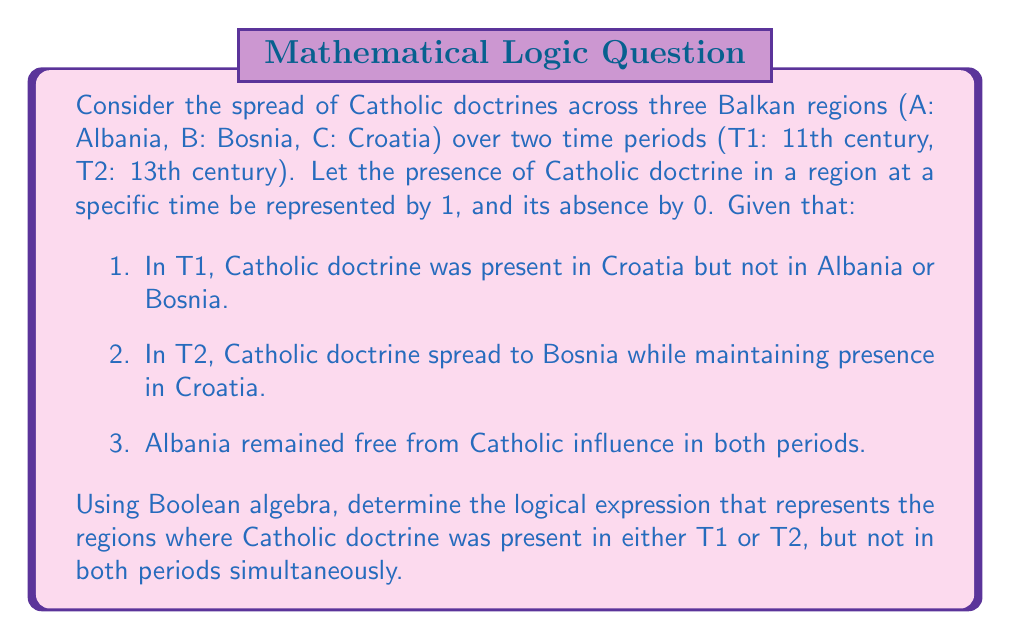Teach me how to tackle this problem. Let's approach this step-by-step using Boolean algebra:

1. First, we'll define our variables:
   $A_1, B_1, C_1$: Presence of Catholic doctrine in Albania, Bosnia, and Croatia respectively in T1
   $A_2, B_2, C_2$: Presence of Catholic doctrine in Albania, Bosnia, and Croatia respectively in T2

2. From the given information:
   $A_1 = 0, B_1 = 0, C_1 = 1$
   $A_2 = 0, B_2 = 1, C_2 = 1$

3. We want to find regions where Catholic doctrine was present in either T1 or T2, but not both. This can be represented by the XOR operation (⊕):

   $(A_1 \oplus A_2) + (B_1 \oplus B_2) + (C_1 \oplus C_2)$

4. Let's evaluate each term:
   $A_1 \oplus A_2 = 0 \oplus 0 = 0$
   $B_1 \oplus B_2 = 0 \oplus 1 = 1$
   $C_1 \oplus C_2 = 1 \oplus 1 = 0$

5. Substituting these values:
   $0 + 1 + 0 = 1$

6. This result indicates that only one region satisfies the condition, which is Bosnia (B).

Therefore, the logical expression representing the regions where Catholic doctrine was present in either T1 or T2, but not in both periods simultaneously, simplifies to just B.
Answer: $B$ 